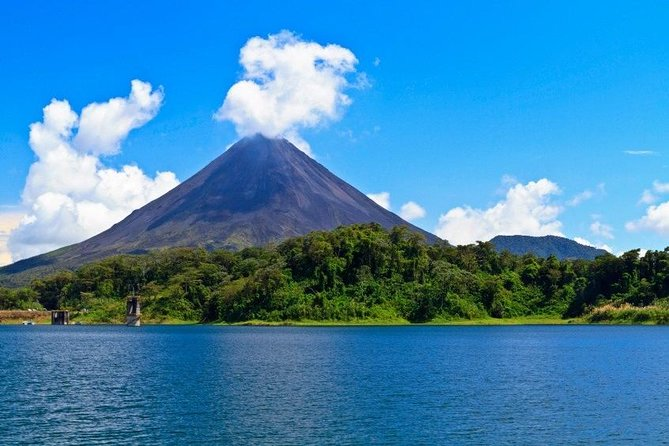What kind of activities can visitors do here? Visitors to the Arenal Volcano region can indulge in a wide range of activities that allow for full immersion in the natural beauty and thrill of the environment. They can hike along the trails through the rainforest to get a closer view of the volcano's lava flows and craters. Water-based activities such as kayaking and fishing are also popular on Arenal Lake. For those seeking relaxation, there are numerous hot springs heated by the geothermal activity of the volcano. Adventure enthusiasts might enjoy zip-lining or canopy tours in the forest, providing a unique perspective on the region's flora and fauna. 